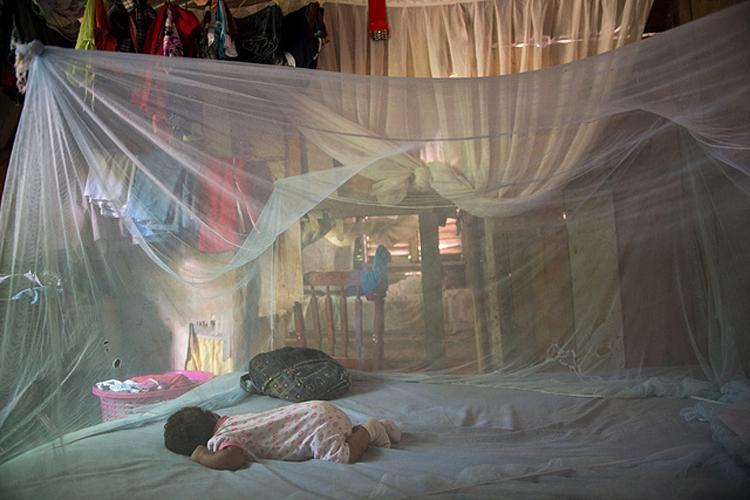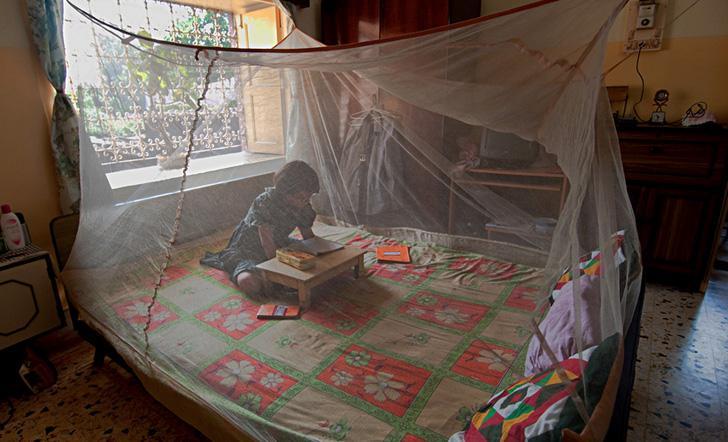The first image is the image on the left, the second image is the image on the right. Given the left and right images, does the statement "There is at least one child in each bed." hold true? Answer yes or no. Yes. 